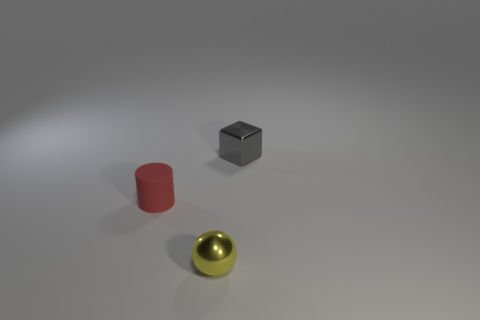What is the shape of the metal thing that is the same size as the metallic cube?
Make the answer very short. Sphere. How big is the matte cylinder?
Offer a terse response. Small. What is the material of the tiny object that is to the right of the metal thing that is in front of the small object that is behind the tiny red thing?
Keep it short and to the point. Metal. The ball that is the same material as the cube is what color?
Offer a terse response. Yellow. What number of gray metallic things are to the left of the thing that is on the right side of the small metallic object in front of the tiny cylinder?
Make the answer very short. 0. Are there any other things that have the same shape as the matte object?
Provide a short and direct response. No. What number of things are either shiny objects behind the red thing or big brown rubber balls?
Keep it short and to the point. 1. There is a tiny metallic thing behind the tiny red object; is its color the same as the ball?
Provide a short and direct response. No. What is the shape of the small thing on the right side of the small object in front of the rubber object?
Your answer should be compact. Cube. Are there fewer cubes behind the yellow ball than tiny gray metal cubes in front of the red thing?
Your response must be concise. No. 